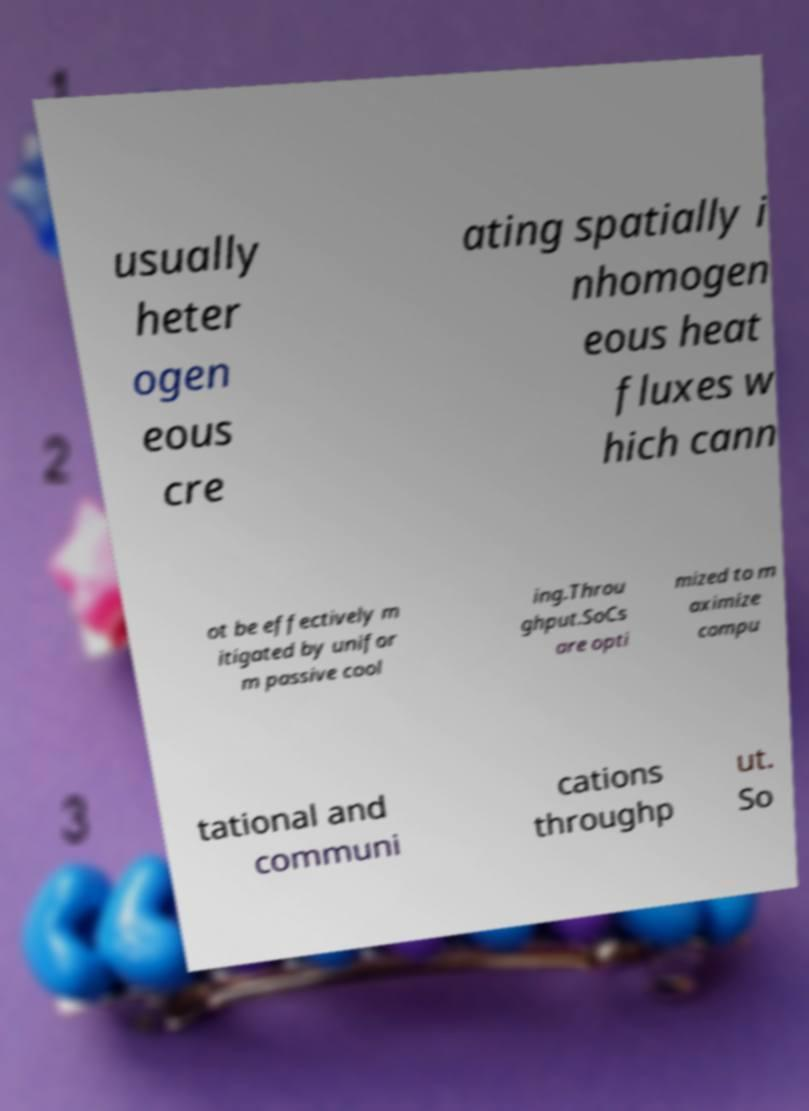Please identify and transcribe the text found in this image. usually heter ogen eous cre ating spatially i nhomogen eous heat fluxes w hich cann ot be effectively m itigated by unifor m passive cool ing.Throu ghput.SoCs are opti mized to m aximize compu tational and communi cations throughp ut. So 